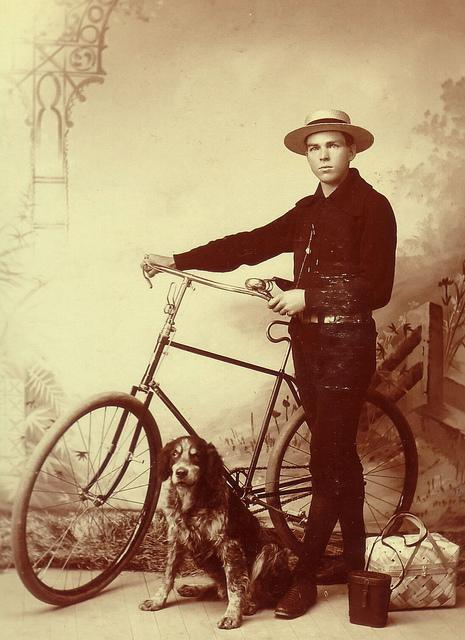What purpose is the bike serving right now? transportation 